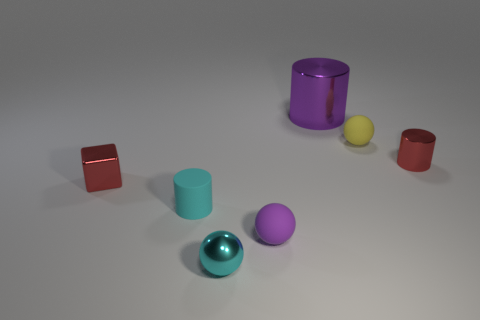Add 3 large gray rubber blocks. How many objects exist? 10 Subtract all cylinders. How many objects are left? 4 Add 5 small purple matte objects. How many small purple matte objects are left? 6 Add 7 purple metallic spheres. How many purple metallic spheres exist? 7 Subtract 0 blue blocks. How many objects are left? 7 Subtract all large gray matte objects. Subtract all cylinders. How many objects are left? 4 